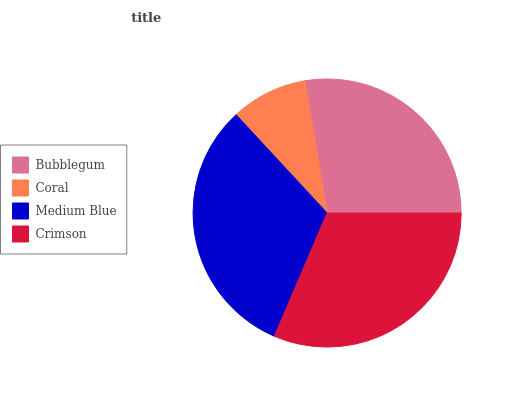Is Coral the minimum?
Answer yes or no. Yes. Is Medium Blue the maximum?
Answer yes or no. Yes. Is Medium Blue the minimum?
Answer yes or no. No. Is Coral the maximum?
Answer yes or no. No. Is Medium Blue greater than Coral?
Answer yes or no. Yes. Is Coral less than Medium Blue?
Answer yes or no. Yes. Is Coral greater than Medium Blue?
Answer yes or no. No. Is Medium Blue less than Coral?
Answer yes or no. No. Is Crimson the high median?
Answer yes or no. Yes. Is Bubblegum the low median?
Answer yes or no. Yes. Is Coral the high median?
Answer yes or no. No. Is Medium Blue the low median?
Answer yes or no. No. 